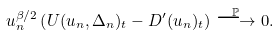Convert formula to latex. <formula><loc_0><loc_0><loc_500><loc_500>u _ { n } ^ { \beta / 2 } \left ( U ( u _ { n } , \Delta _ { n } ) _ { t } - D ^ { \prime } ( u _ { n } ) _ { t } \right ) \stackrel { \mathbb { P } } { \longrightarrow } 0 .</formula> 